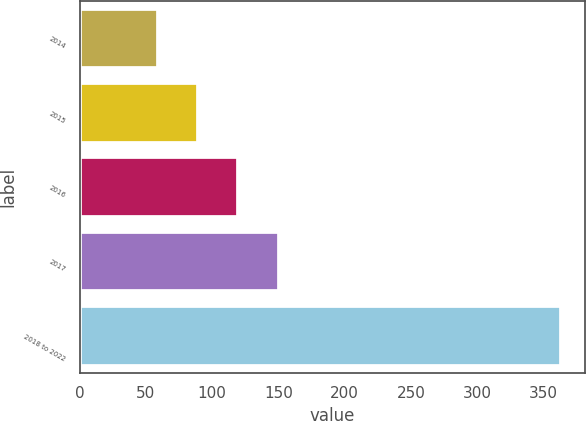Convert chart. <chart><loc_0><loc_0><loc_500><loc_500><bar_chart><fcel>2014<fcel>2015<fcel>2016<fcel>2017<fcel>2018 to 2022<nl><fcel>59<fcel>89.4<fcel>119.8<fcel>150.2<fcel>363<nl></chart> 